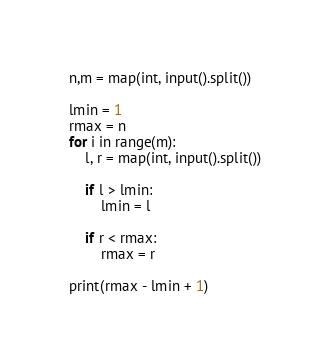<code> <loc_0><loc_0><loc_500><loc_500><_Python_>n,m = map(int, input().split())

lmin = 1
rmax = n
for i in range(m):
    l, r = map(int, input().split())

    if l > lmin:
        lmin = l

    if r < rmax:
        rmax = r

print(rmax - lmin + 1)  </code> 